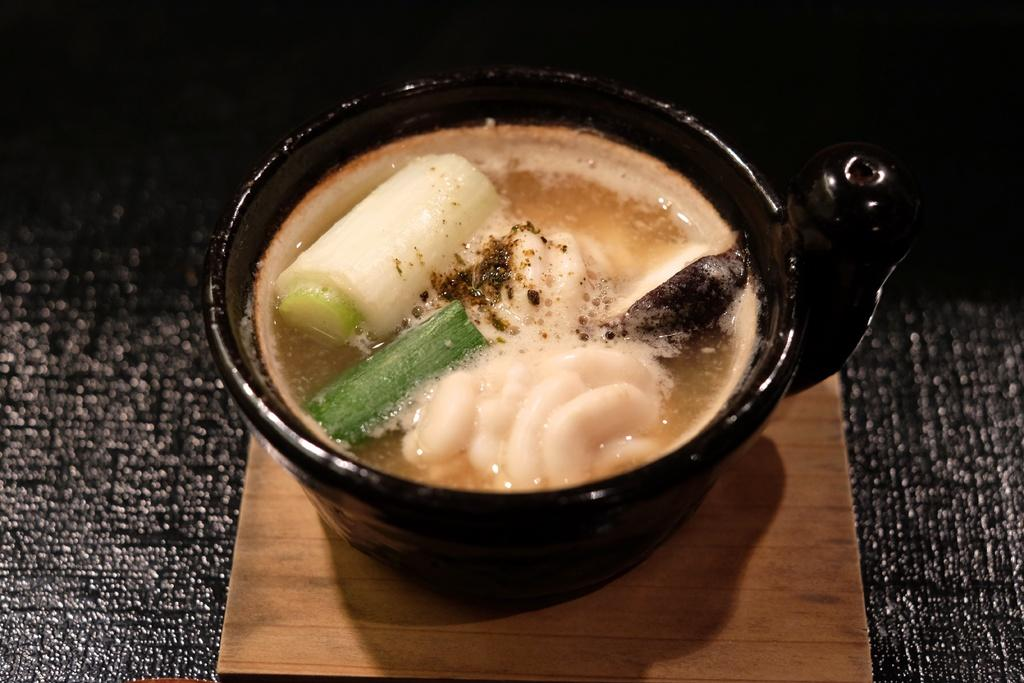What color is the cup in the image? The cup in the image is black. Where is the cup placed? The cup is placed on a wooden plank. What is the wooden plank placed on? The wooden plank is placed on a black color mat. What is inside the cup? There is a drink in the cup. How many parents are present in the image? There are no parents present in the image; it only features a black color cup, a wooden plank, a black color mat, and a drink inside the cup. 